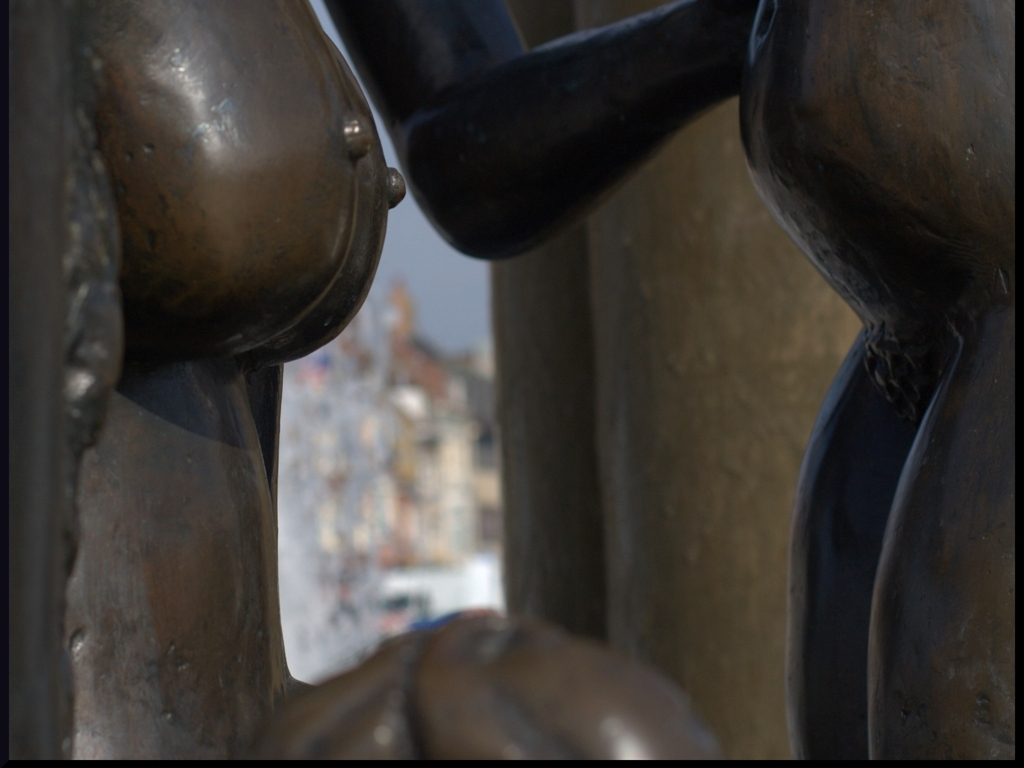What can you infer about the location featured in the image? Based on the architectural style seen in the blurred background and the patina on the bronze sculpture, it could be inferred that this image is located in an area with historical significance, possibly in Europe. Does the time of day have an effect on the image? Yes, the lighting suggests it may be taken during the golden hour, which enhances the textures and the three-dimensional quality of the sculpture while giving the cityscape a warm, ethereal glow. 